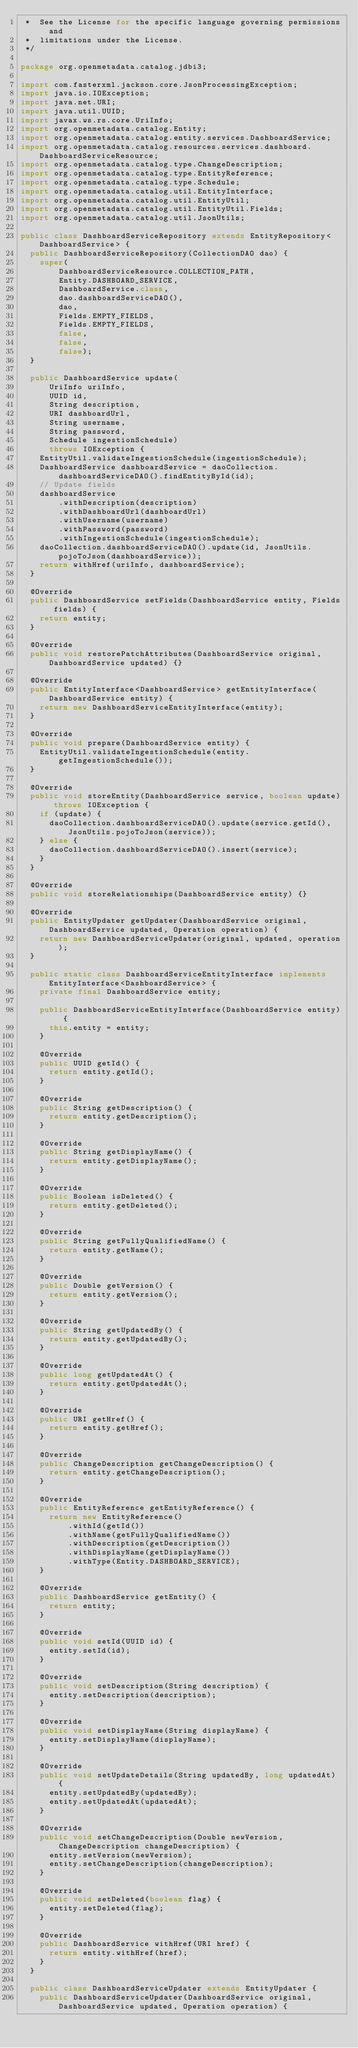Convert code to text. <code><loc_0><loc_0><loc_500><loc_500><_Java_> *  See the License for the specific language governing permissions and
 *  limitations under the License.
 */

package org.openmetadata.catalog.jdbi3;

import com.fasterxml.jackson.core.JsonProcessingException;
import java.io.IOException;
import java.net.URI;
import java.util.UUID;
import javax.ws.rs.core.UriInfo;
import org.openmetadata.catalog.Entity;
import org.openmetadata.catalog.entity.services.DashboardService;
import org.openmetadata.catalog.resources.services.dashboard.DashboardServiceResource;
import org.openmetadata.catalog.type.ChangeDescription;
import org.openmetadata.catalog.type.EntityReference;
import org.openmetadata.catalog.type.Schedule;
import org.openmetadata.catalog.util.EntityInterface;
import org.openmetadata.catalog.util.EntityUtil;
import org.openmetadata.catalog.util.EntityUtil.Fields;
import org.openmetadata.catalog.util.JsonUtils;

public class DashboardServiceRepository extends EntityRepository<DashboardService> {
  public DashboardServiceRepository(CollectionDAO dao) {
    super(
        DashboardServiceResource.COLLECTION_PATH,
        Entity.DASHBOARD_SERVICE,
        DashboardService.class,
        dao.dashboardServiceDAO(),
        dao,
        Fields.EMPTY_FIELDS,
        Fields.EMPTY_FIELDS,
        false,
        false,
        false);
  }

  public DashboardService update(
      UriInfo uriInfo,
      UUID id,
      String description,
      URI dashboardUrl,
      String username,
      String password,
      Schedule ingestionSchedule)
      throws IOException {
    EntityUtil.validateIngestionSchedule(ingestionSchedule);
    DashboardService dashboardService = daoCollection.dashboardServiceDAO().findEntityById(id);
    // Update fields
    dashboardService
        .withDescription(description)
        .withDashboardUrl(dashboardUrl)
        .withUsername(username)
        .withPassword(password)
        .withIngestionSchedule(ingestionSchedule);
    daoCollection.dashboardServiceDAO().update(id, JsonUtils.pojoToJson(dashboardService));
    return withHref(uriInfo, dashboardService);
  }

  @Override
  public DashboardService setFields(DashboardService entity, Fields fields) {
    return entity;
  }

  @Override
  public void restorePatchAttributes(DashboardService original, DashboardService updated) {}

  @Override
  public EntityInterface<DashboardService> getEntityInterface(DashboardService entity) {
    return new DashboardServiceEntityInterface(entity);
  }

  @Override
  public void prepare(DashboardService entity) {
    EntityUtil.validateIngestionSchedule(entity.getIngestionSchedule());
  }

  @Override
  public void storeEntity(DashboardService service, boolean update) throws IOException {
    if (update) {
      daoCollection.dashboardServiceDAO().update(service.getId(), JsonUtils.pojoToJson(service));
    } else {
      daoCollection.dashboardServiceDAO().insert(service);
    }
  }

  @Override
  public void storeRelationships(DashboardService entity) {}

  @Override
  public EntityUpdater getUpdater(DashboardService original, DashboardService updated, Operation operation) {
    return new DashboardServiceUpdater(original, updated, operation);
  }

  public static class DashboardServiceEntityInterface implements EntityInterface<DashboardService> {
    private final DashboardService entity;

    public DashboardServiceEntityInterface(DashboardService entity) {
      this.entity = entity;
    }

    @Override
    public UUID getId() {
      return entity.getId();
    }

    @Override
    public String getDescription() {
      return entity.getDescription();
    }

    @Override
    public String getDisplayName() {
      return entity.getDisplayName();
    }

    @Override
    public Boolean isDeleted() {
      return entity.getDeleted();
    }

    @Override
    public String getFullyQualifiedName() {
      return entity.getName();
    }

    @Override
    public Double getVersion() {
      return entity.getVersion();
    }

    @Override
    public String getUpdatedBy() {
      return entity.getUpdatedBy();
    }

    @Override
    public long getUpdatedAt() {
      return entity.getUpdatedAt();
    }

    @Override
    public URI getHref() {
      return entity.getHref();
    }

    @Override
    public ChangeDescription getChangeDescription() {
      return entity.getChangeDescription();
    }

    @Override
    public EntityReference getEntityReference() {
      return new EntityReference()
          .withId(getId())
          .withName(getFullyQualifiedName())
          .withDescription(getDescription())
          .withDisplayName(getDisplayName())
          .withType(Entity.DASHBOARD_SERVICE);
    }

    @Override
    public DashboardService getEntity() {
      return entity;
    }

    @Override
    public void setId(UUID id) {
      entity.setId(id);
    }

    @Override
    public void setDescription(String description) {
      entity.setDescription(description);
    }

    @Override
    public void setDisplayName(String displayName) {
      entity.setDisplayName(displayName);
    }

    @Override
    public void setUpdateDetails(String updatedBy, long updatedAt) {
      entity.setUpdatedBy(updatedBy);
      entity.setUpdatedAt(updatedAt);
    }

    @Override
    public void setChangeDescription(Double newVersion, ChangeDescription changeDescription) {
      entity.setVersion(newVersion);
      entity.setChangeDescription(changeDescription);
    }

    @Override
    public void setDeleted(boolean flag) {
      entity.setDeleted(flag);
    }

    @Override
    public DashboardService withHref(URI href) {
      return entity.withHref(href);
    }
  }

  public class DashboardServiceUpdater extends EntityUpdater {
    public DashboardServiceUpdater(DashboardService original, DashboardService updated, Operation operation) {</code> 